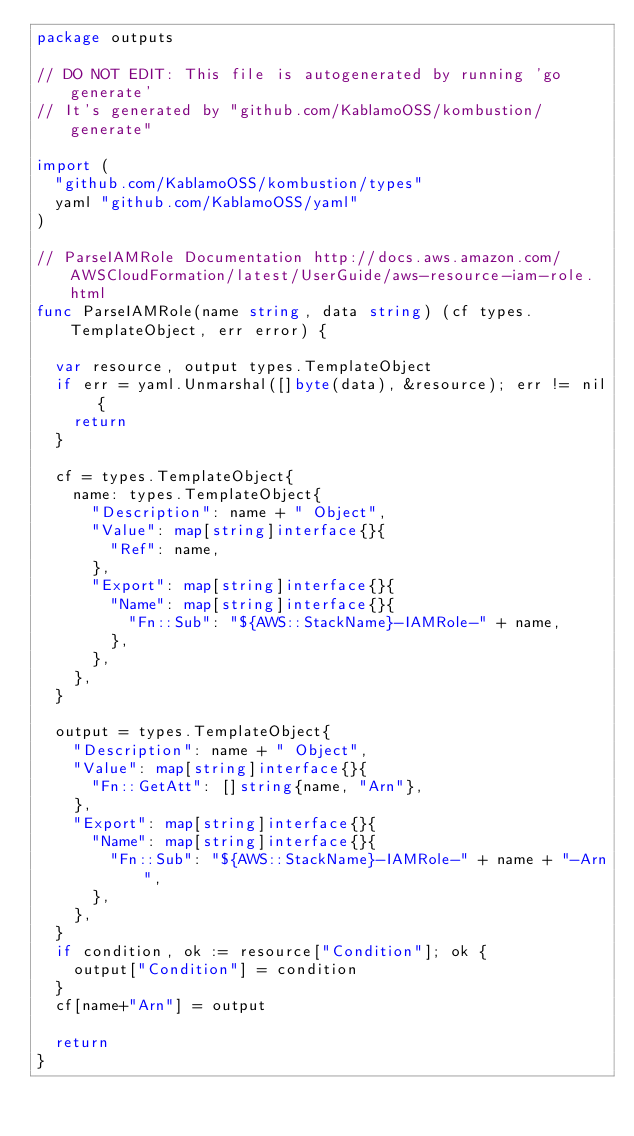Convert code to text. <code><loc_0><loc_0><loc_500><loc_500><_Go_>package outputs

// DO NOT EDIT: This file is autogenerated by running 'go generate'
// It's generated by "github.com/KablamoOSS/kombustion/generate"

import (
	"github.com/KablamoOSS/kombustion/types"
	yaml "github.com/KablamoOSS/yaml"
)

// ParseIAMRole Documentation http://docs.aws.amazon.com/AWSCloudFormation/latest/UserGuide/aws-resource-iam-role.html
func ParseIAMRole(name string, data string) (cf types.TemplateObject, err error) {

	var resource, output types.TemplateObject
	if err = yaml.Unmarshal([]byte(data), &resource); err != nil {
		return
	}

	cf = types.TemplateObject{
		name: types.TemplateObject{
			"Description": name + " Object",
			"Value": map[string]interface{}{
				"Ref": name,
			},
			"Export": map[string]interface{}{
				"Name": map[string]interface{}{
					"Fn::Sub": "${AWS::StackName}-IAMRole-" + name,
				},
			},
		},
	}

	output = types.TemplateObject{
		"Description": name + " Object",
		"Value": map[string]interface{}{
			"Fn::GetAtt": []string{name, "Arn"},
		},
		"Export": map[string]interface{}{
			"Name": map[string]interface{}{
				"Fn::Sub": "${AWS::StackName}-IAMRole-" + name + "-Arn",
			},
		},
	}
	if condition, ok := resource["Condition"]; ok {
		output["Condition"] = condition
	}
	cf[name+"Arn"] = output

	return
}
</code> 